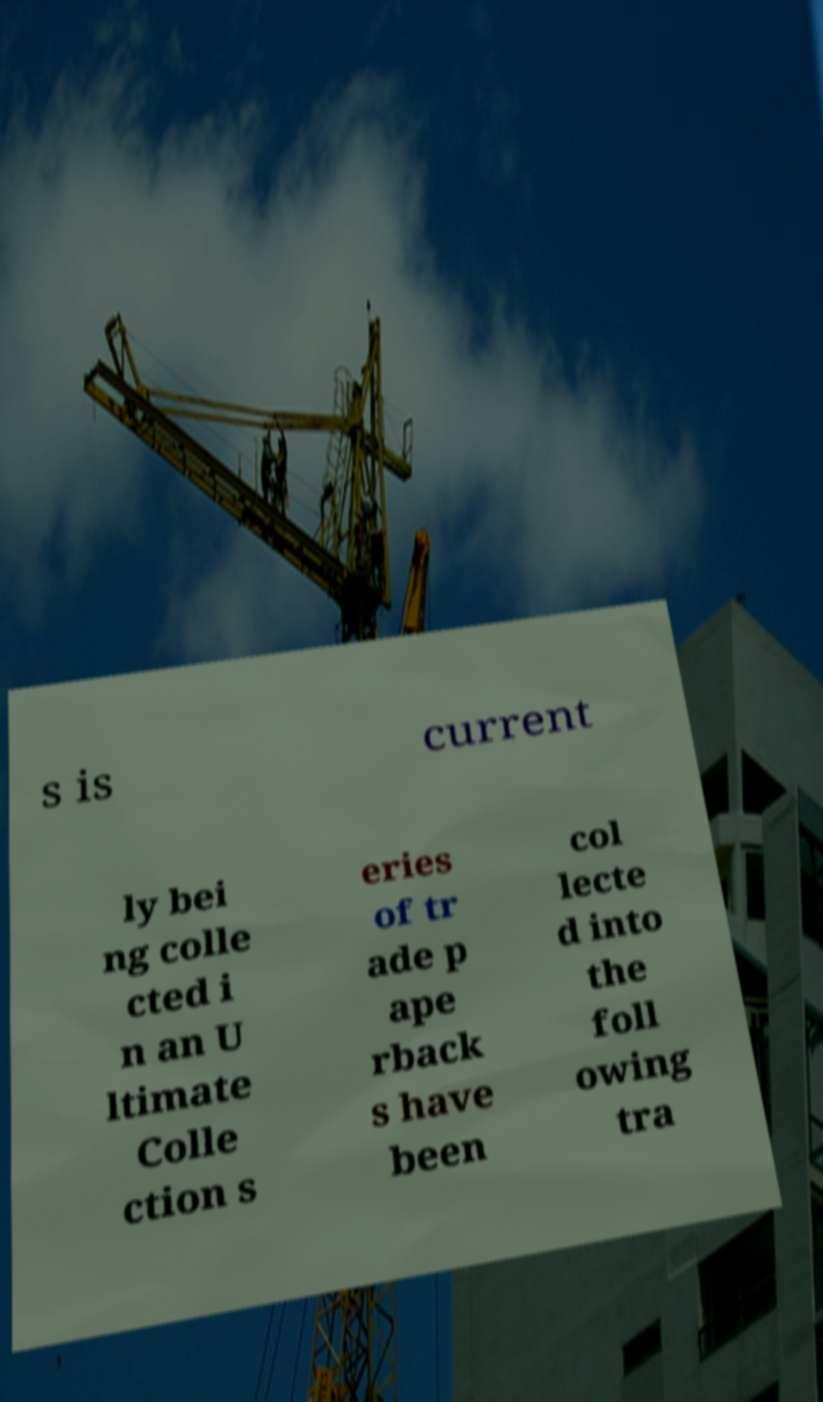Please read and relay the text visible in this image. What does it say? s is current ly bei ng colle cted i n an U ltimate Colle ction s eries of tr ade p ape rback s have been col lecte d into the foll owing tra 